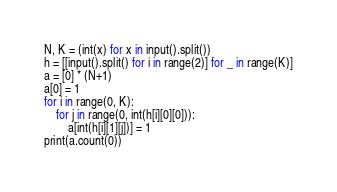<code> <loc_0><loc_0><loc_500><loc_500><_Python_>N, K = (int(x) for x in input().split())
h = [[input().split() for i in range(2)] for _ in range(K)]
a = [0] * (N+1)
a[0] = 1
for i in range(0, K):
    for j in range(0, int(h[i][0][0])):
        a[int(h[i][1][j])] = 1
print(a.count(0))</code> 